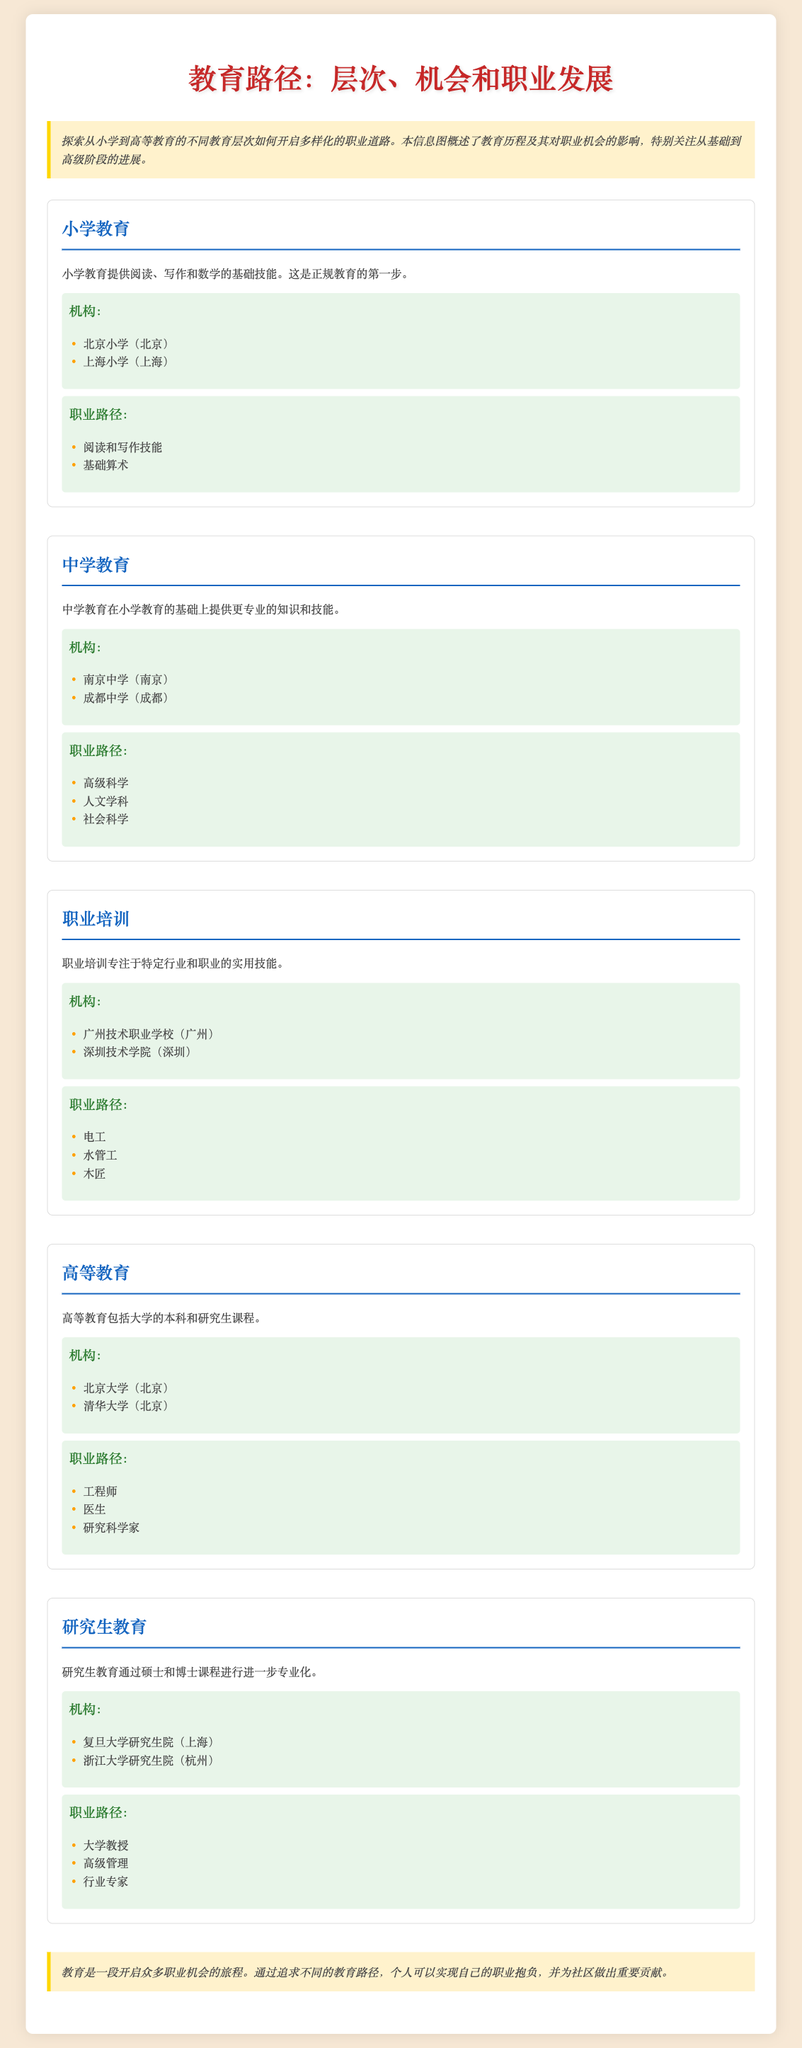what is the first level of education mentioned? The first level of education mentioned in the infographic is primary education.
Answer: 小学教育 which two universities are highlighted in higher education? The infographic lists Beijing University and Tsinghua University under higher education institutions.
Answer: 北京大学, 清华大学 what type of skills does vocational training focus on? Vocational training focuses on practical skills for specific industries and jobs.
Answer: 实用技能 how many career pathways are listed under graduate education? There are three career pathways listed under graduate education in the infographic.
Answer: 三个 name one institution mentioned for middle school education. An example of a middle school institution provided is Nanjing Middle School.
Answer: 南京中学 which level of education provides reading and writing skills? The level that provides reading and writing skills is primary education.
Answer: 小学教育 what are the career pathways associated with vocational training? The career pathways associated with vocational training are electrician, plumber, and carpenter.
Answer: 电工, 水管工, 木匠 what degrees are included in graduate education? Graduate education includes master's and doctoral programs.
Answer: 硕士和博士课程 